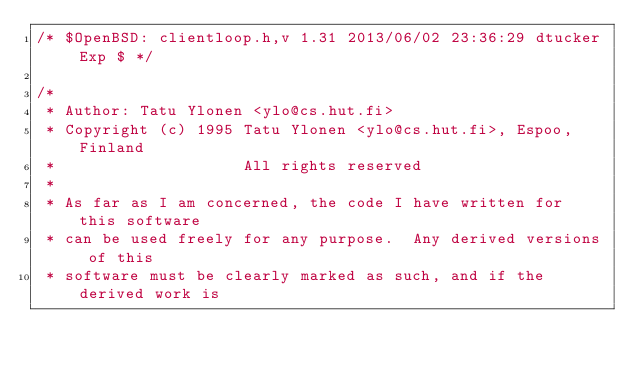<code> <loc_0><loc_0><loc_500><loc_500><_C_>/* $OpenBSD: clientloop.h,v 1.31 2013/06/02 23:36:29 dtucker Exp $ */

/*
 * Author: Tatu Ylonen <ylo@cs.hut.fi>
 * Copyright (c) 1995 Tatu Ylonen <ylo@cs.hut.fi>, Espoo, Finland
 *                    All rights reserved
 *
 * As far as I am concerned, the code I have written for this software
 * can be used freely for any purpose.  Any derived versions of this
 * software must be clearly marked as such, and if the derived work is</code> 